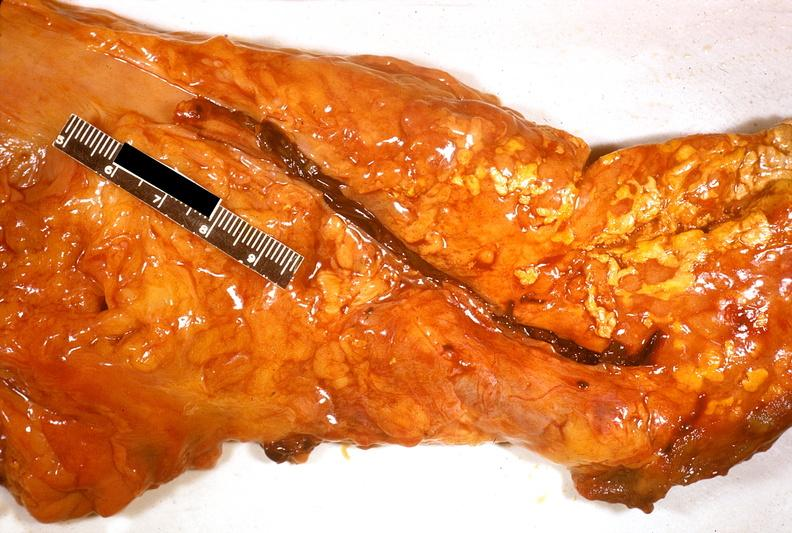what does this image show?
Answer the question using a single word or phrase. Acute pancreatitis 